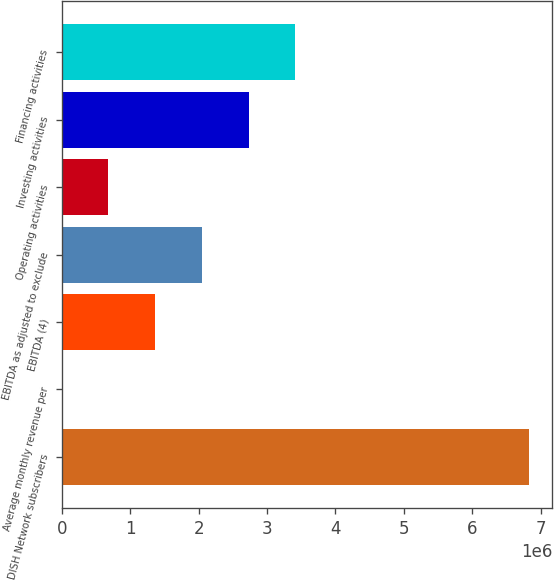Convert chart. <chart><loc_0><loc_0><loc_500><loc_500><bar_chart><fcel>DISH Network subscribers<fcel>Average monthly revenue per<fcel>EBITDA (4)<fcel>EBITDA as adjusted to exclude<fcel>Operating activities<fcel>Investing activities<fcel>Financing activities<nl><fcel>6.83e+06<fcel>49.32<fcel>1.36604e+06<fcel>2.04903e+06<fcel>683044<fcel>2.73203e+06<fcel>3.41502e+06<nl></chart> 